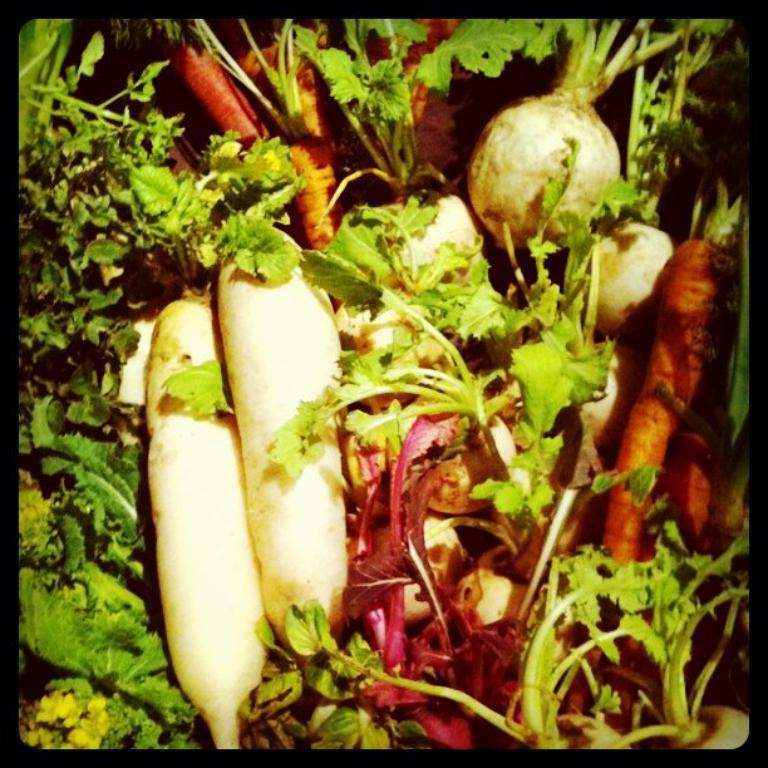How would you summarize this image in a sentence or two? In this image I can see many vegetables which are in green, pink, orange and cream color. 